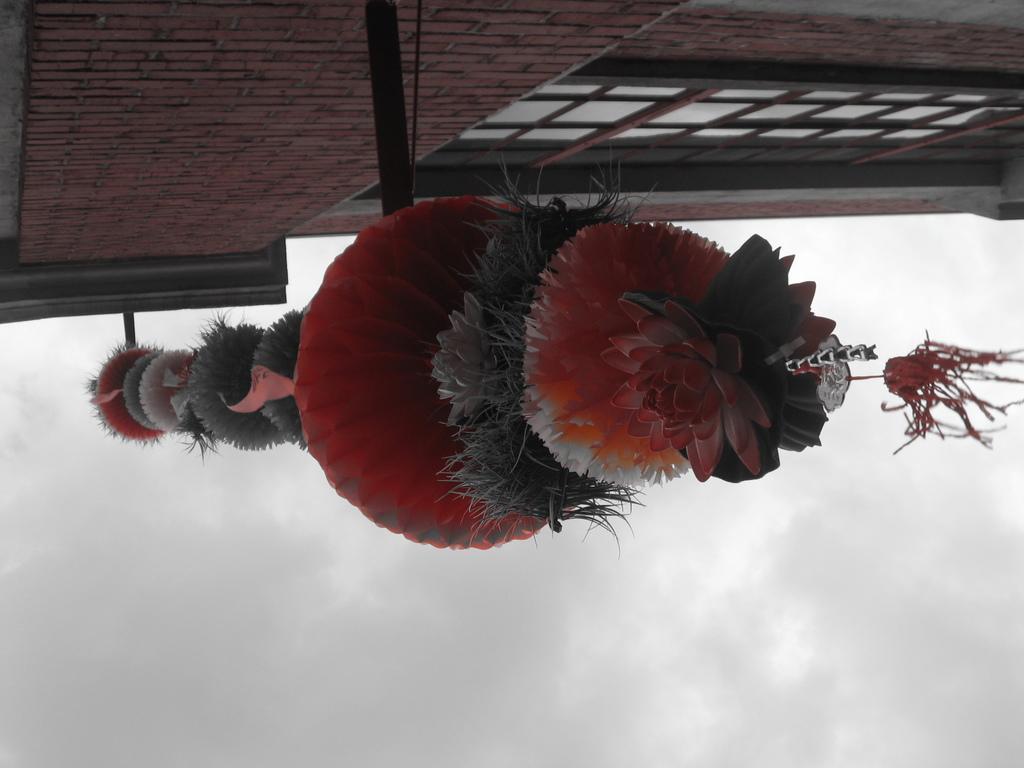Could you give a brief overview of what you see in this image? In the middle of this image, there is a decorative item attached to a wall of a building which is having windows. In the background, there are clouds in the sky. 